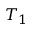Convert formula to latex. <formula><loc_0><loc_0><loc_500><loc_500>T _ { 1 }</formula> 